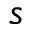<formula> <loc_0><loc_0><loc_500><loc_500>s</formula> 